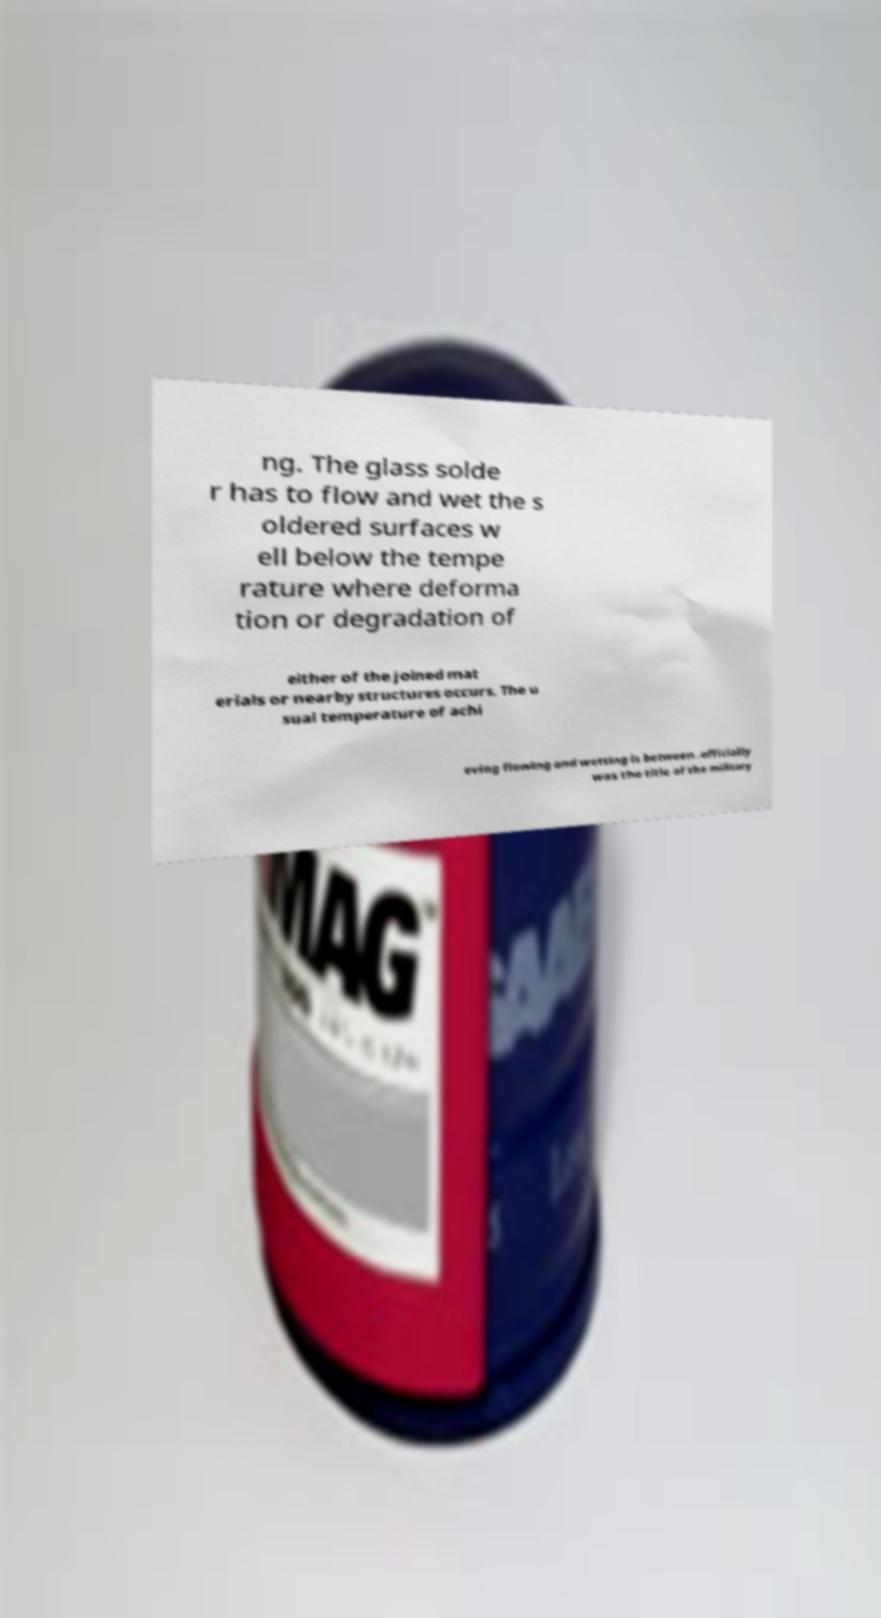Can you read and provide the text displayed in the image?This photo seems to have some interesting text. Can you extract and type it out for me? ng. The glass solde r has to flow and wet the s oldered surfaces w ell below the tempe rature where deforma tion or degradation of either of the joined mat erials or nearby structures occurs. The u sual temperature of achi eving flowing and wetting is between .officially was the title of the military 